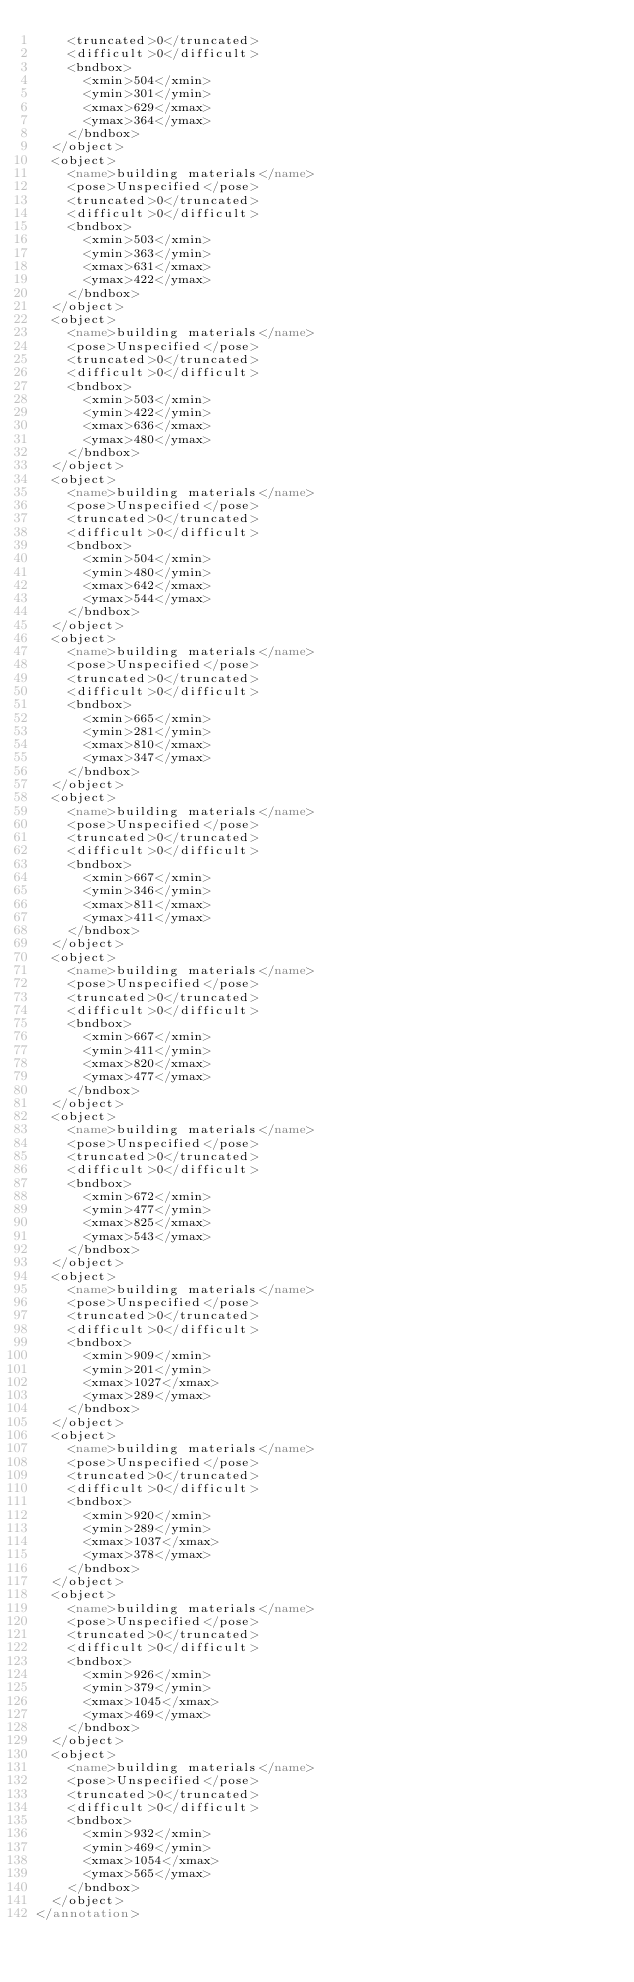<code> <loc_0><loc_0><loc_500><loc_500><_XML_>		<truncated>0</truncated>
		<difficult>0</difficult>
		<bndbox>
			<xmin>504</xmin>
			<ymin>301</ymin>
			<xmax>629</xmax>
			<ymax>364</ymax>
		</bndbox>
	</object>
	<object>
		<name>building materials</name>
		<pose>Unspecified</pose>
		<truncated>0</truncated>
		<difficult>0</difficult>
		<bndbox>
			<xmin>503</xmin>
			<ymin>363</ymin>
			<xmax>631</xmax>
			<ymax>422</ymax>
		</bndbox>
	</object>
	<object>
		<name>building materials</name>
		<pose>Unspecified</pose>
		<truncated>0</truncated>
		<difficult>0</difficult>
		<bndbox>
			<xmin>503</xmin>
			<ymin>422</ymin>
			<xmax>636</xmax>
			<ymax>480</ymax>
		</bndbox>
	</object>
	<object>
		<name>building materials</name>
		<pose>Unspecified</pose>
		<truncated>0</truncated>
		<difficult>0</difficult>
		<bndbox>
			<xmin>504</xmin>
			<ymin>480</ymin>
			<xmax>642</xmax>
			<ymax>544</ymax>
		</bndbox>
	</object>
	<object>
		<name>building materials</name>
		<pose>Unspecified</pose>
		<truncated>0</truncated>
		<difficult>0</difficult>
		<bndbox>
			<xmin>665</xmin>
			<ymin>281</ymin>
			<xmax>810</xmax>
			<ymax>347</ymax>
		</bndbox>
	</object>
	<object>
		<name>building materials</name>
		<pose>Unspecified</pose>
		<truncated>0</truncated>
		<difficult>0</difficult>
		<bndbox>
			<xmin>667</xmin>
			<ymin>346</ymin>
			<xmax>811</xmax>
			<ymax>411</ymax>
		</bndbox>
	</object>
	<object>
		<name>building materials</name>
		<pose>Unspecified</pose>
		<truncated>0</truncated>
		<difficult>0</difficult>
		<bndbox>
			<xmin>667</xmin>
			<ymin>411</ymin>
			<xmax>820</xmax>
			<ymax>477</ymax>
		</bndbox>
	</object>
	<object>
		<name>building materials</name>
		<pose>Unspecified</pose>
		<truncated>0</truncated>
		<difficult>0</difficult>
		<bndbox>
			<xmin>672</xmin>
			<ymin>477</ymin>
			<xmax>825</xmax>
			<ymax>543</ymax>
		</bndbox>
	</object>
	<object>
		<name>building materials</name>
		<pose>Unspecified</pose>
		<truncated>0</truncated>
		<difficult>0</difficult>
		<bndbox>
			<xmin>909</xmin>
			<ymin>201</ymin>
			<xmax>1027</xmax>
			<ymax>289</ymax>
		</bndbox>
	</object>
	<object>
		<name>building materials</name>
		<pose>Unspecified</pose>
		<truncated>0</truncated>
		<difficult>0</difficult>
		<bndbox>
			<xmin>920</xmin>
			<ymin>289</ymin>
			<xmax>1037</xmax>
			<ymax>378</ymax>
		</bndbox>
	</object>
	<object>
		<name>building materials</name>
		<pose>Unspecified</pose>
		<truncated>0</truncated>
		<difficult>0</difficult>
		<bndbox>
			<xmin>926</xmin>
			<ymin>379</ymin>
			<xmax>1045</xmax>
			<ymax>469</ymax>
		</bndbox>
	</object>
	<object>
		<name>building materials</name>
		<pose>Unspecified</pose>
		<truncated>0</truncated>
		<difficult>0</difficult>
		<bndbox>
			<xmin>932</xmin>
			<ymin>469</ymin>
			<xmax>1054</xmax>
			<ymax>565</ymax>
		</bndbox>
	</object>
</annotation>
</code> 